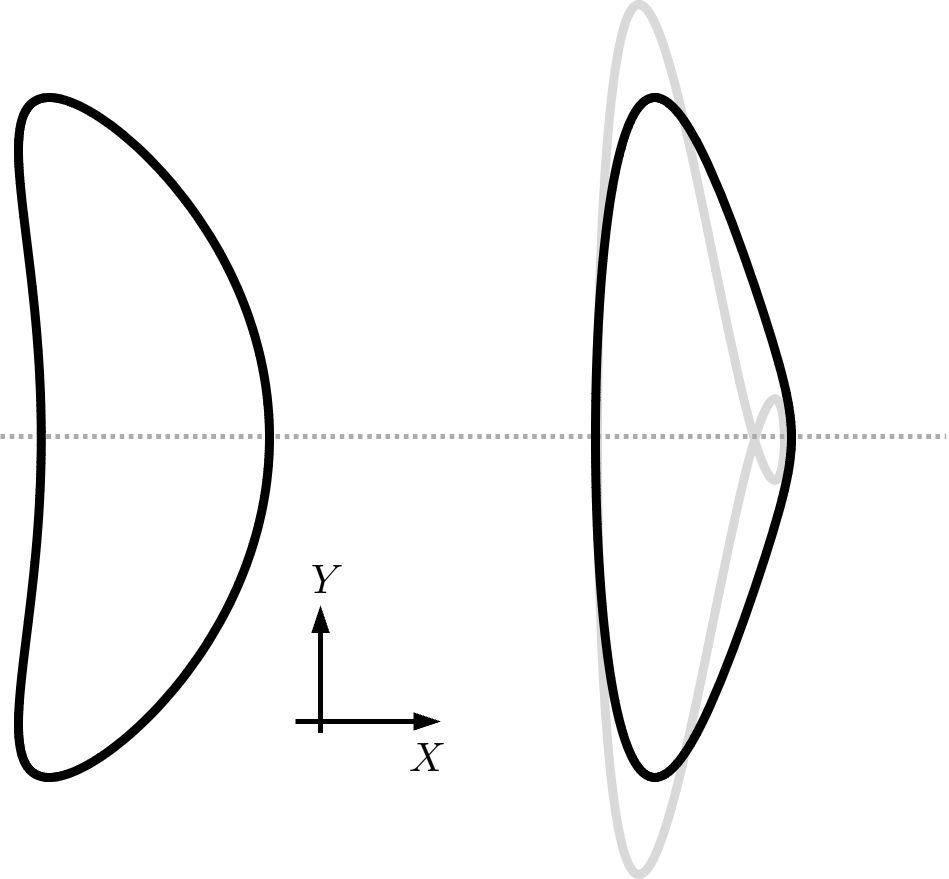Which geometric property is preserved in the transformation shown in the figure? A. Area B. Perimeter C. Angle measures D. Side ratios - In a dilation transformation, the angle measures are preserved while the side lengths are scaled. This can be inferred from the figure, as the shape appears to maintain its overall proportions and angles while changing in size. Therefore, the correct answer is C. Angle measures. 